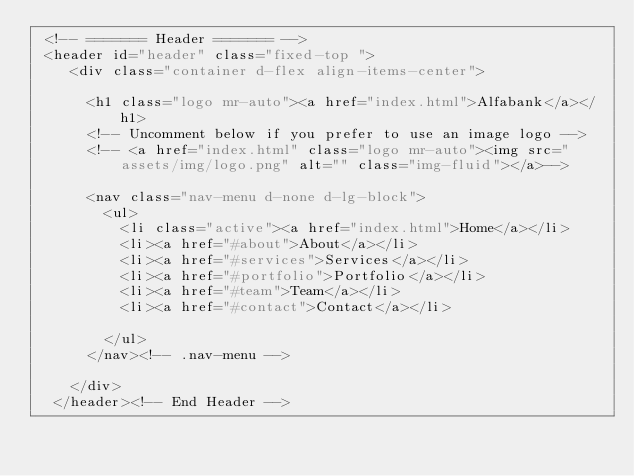<code> <loc_0><loc_0><loc_500><loc_500><_PHP_> <!-- ======= Header ======= -->
 <header id="header" class="fixed-top ">
    <div class="container d-flex align-items-center">

      <h1 class="logo mr-auto"><a href="index.html">Alfabank</a></h1>
      <!-- Uncomment below if you prefer to use an image logo -->
      <!-- <a href="index.html" class="logo mr-auto"><img src="assets/img/logo.png" alt="" class="img-fluid"></a>-->

      <nav class="nav-menu d-none d-lg-block">
        <ul>
          <li class="active"><a href="index.html">Home</a></li>
          <li><a href="#about">About</a></li>
          <li><a href="#services">Services</a></li>
          <li><a href="#portfolio">Portfolio</a></li>
          <li><a href="#team">Team</a></li>
          <li><a href="#contact">Contact</a></li>

        </ul>
      </nav><!-- .nav-menu -->

    </div>
  </header><!-- End Header -->
</code> 